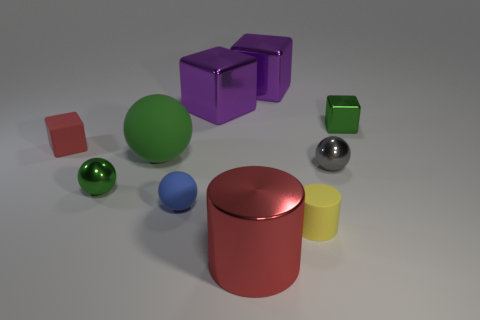Subtract all small spheres. How many spheres are left? 1 Subtract all balls. How many objects are left? 6 Subtract 4 blocks. How many blocks are left? 0 Subtract all large cylinders. Subtract all yellow rubber objects. How many objects are left? 8 Add 9 big metal cylinders. How many big metal cylinders are left? 10 Add 6 green shiny cubes. How many green shiny cubes exist? 7 Subtract all red blocks. How many blocks are left? 3 Subtract 0 cyan cubes. How many objects are left? 10 Subtract all gray spheres. Subtract all brown blocks. How many spheres are left? 3 Subtract all blue cylinders. How many purple blocks are left? 2 